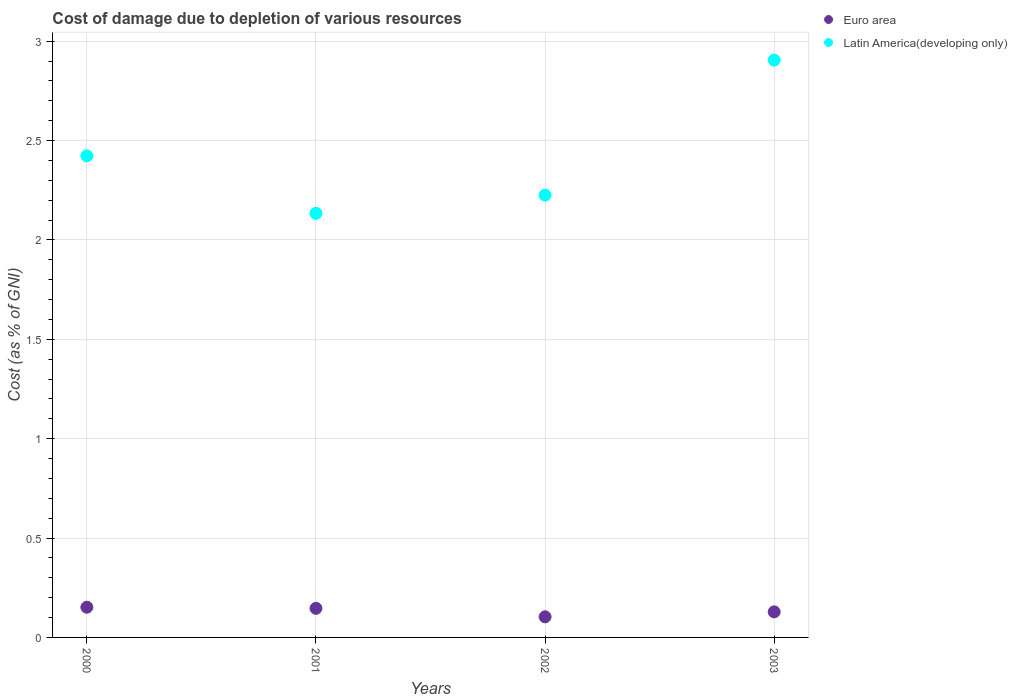How many different coloured dotlines are there?
Keep it short and to the point. 2. Is the number of dotlines equal to the number of legend labels?
Provide a short and direct response. Yes. What is the cost of damage caused due to the depletion of various resources in Euro area in 2002?
Keep it short and to the point. 0.1. Across all years, what is the maximum cost of damage caused due to the depletion of various resources in Euro area?
Give a very brief answer. 0.15. Across all years, what is the minimum cost of damage caused due to the depletion of various resources in Euro area?
Your response must be concise. 0.1. In which year was the cost of damage caused due to the depletion of various resources in Euro area maximum?
Provide a short and direct response. 2000. What is the total cost of damage caused due to the depletion of various resources in Latin America(developing only) in the graph?
Ensure brevity in your answer.  9.69. What is the difference between the cost of damage caused due to the depletion of various resources in Latin America(developing only) in 2000 and that in 2002?
Offer a very short reply. 0.2. What is the difference between the cost of damage caused due to the depletion of various resources in Latin America(developing only) in 2002 and the cost of damage caused due to the depletion of various resources in Euro area in 2000?
Keep it short and to the point. 2.07. What is the average cost of damage caused due to the depletion of various resources in Latin America(developing only) per year?
Keep it short and to the point. 2.42. In the year 2002, what is the difference between the cost of damage caused due to the depletion of various resources in Latin America(developing only) and cost of damage caused due to the depletion of various resources in Euro area?
Ensure brevity in your answer.  2.12. What is the ratio of the cost of damage caused due to the depletion of various resources in Latin America(developing only) in 2002 to that in 2003?
Your response must be concise. 0.77. What is the difference between the highest and the second highest cost of damage caused due to the depletion of various resources in Euro area?
Your answer should be compact. 0.01. What is the difference between the highest and the lowest cost of damage caused due to the depletion of various resources in Euro area?
Your answer should be compact. 0.05. Is the sum of the cost of damage caused due to the depletion of various resources in Latin America(developing only) in 2000 and 2003 greater than the maximum cost of damage caused due to the depletion of various resources in Euro area across all years?
Offer a terse response. Yes. Does the cost of damage caused due to the depletion of various resources in Euro area monotonically increase over the years?
Your answer should be very brief. No. How many dotlines are there?
Your answer should be compact. 2. How many years are there in the graph?
Offer a terse response. 4. Are the values on the major ticks of Y-axis written in scientific E-notation?
Give a very brief answer. No. Where does the legend appear in the graph?
Ensure brevity in your answer.  Top right. How many legend labels are there?
Give a very brief answer. 2. What is the title of the graph?
Keep it short and to the point. Cost of damage due to depletion of various resources. Does "Isle of Man" appear as one of the legend labels in the graph?
Make the answer very short. No. What is the label or title of the Y-axis?
Your answer should be compact. Cost (as % of GNI). What is the Cost (as % of GNI) of Euro area in 2000?
Provide a short and direct response. 0.15. What is the Cost (as % of GNI) of Latin America(developing only) in 2000?
Offer a terse response. 2.42. What is the Cost (as % of GNI) of Euro area in 2001?
Keep it short and to the point. 0.15. What is the Cost (as % of GNI) of Latin America(developing only) in 2001?
Keep it short and to the point. 2.13. What is the Cost (as % of GNI) in Euro area in 2002?
Provide a succinct answer. 0.1. What is the Cost (as % of GNI) of Latin America(developing only) in 2002?
Offer a terse response. 2.23. What is the Cost (as % of GNI) in Euro area in 2003?
Keep it short and to the point. 0.13. What is the Cost (as % of GNI) in Latin America(developing only) in 2003?
Your answer should be compact. 2.91. Across all years, what is the maximum Cost (as % of GNI) in Euro area?
Your answer should be very brief. 0.15. Across all years, what is the maximum Cost (as % of GNI) in Latin America(developing only)?
Ensure brevity in your answer.  2.91. Across all years, what is the minimum Cost (as % of GNI) of Euro area?
Ensure brevity in your answer.  0.1. Across all years, what is the minimum Cost (as % of GNI) in Latin America(developing only)?
Your response must be concise. 2.13. What is the total Cost (as % of GNI) of Euro area in the graph?
Provide a short and direct response. 0.53. What is the total Cost (as % of GNI) of Latin America(developing only) in the graph?
Make the answer very short. 9.69. What is the difference between the Cost (as % of GNI) of Euro area in 2000 and that in 2001?
Provide a succinct answer. 0.01. What is the difference between the Cost (as % of GNI) of Latin America(developing only) in 2000 and that in 2001?
Make the answer very short. 0.29. What is the difference between the Cost (as % of GNI) of Euro area in 2000 and that in 2002?
Keep it short and to the point. 0.05. What is the difference between the Cost (as % of GNI) of Latin America(developing only) in 2000 and that in 2002?
Your answer should be compact. 0.2. What is the difference between the Cost (as % of GNI) of Euro area in 2000 and that in 2003?
Your answer should be compact. 0.02. What is the difference between the Cost (as % of GNI) in Latin America(developing only) in 2000 and that in 2003?
Offer a very short reply. -0.48. What is the difference between the Cost (as % of GNI) in Euro area in 2001 and that in 2002?
Make the answer very short. 0.04. What is the difference between the Cost (as % of GNI) in Latin America(developing only) in 2001 and that in 2002?
Make the answer very short. -0.09. What is the difference between the Cost (as % of GNI) in Euro area in 2001 and that in 2003?
Offer a terse response. 0.02. What is the difference between the Cost (as % of GNI) in Latin America(developing only) in 2001 and that in 2003?
Ensure brevity in your answer.  -0.77. What is the difference between the Cost (as % of GNI) in Euro area in 2002 and that in 2003?
Keep it short and to the point. -0.03. What is the difference between the Cost (as % of GNI) of Latin America(developing only) in 2002 and that in 2003?
Ensure brevity in your answer.  -0.68. What is the difference between the Cost (as % of GNI) in Euro area in 2000 and the Cost (as % of GNI) in Latin America(developing only) in 2001?
Provide a succinct answer. -1.98. What is the difference between the Cost (as % of GNI) of Euro area in 2000 and the Cost (as % of GNI) of Latin America(developing only) in 2002?
Provide a short and direct response. -2.07. What is the difference between the Cost (as % of GNI) in Euro area in 2000 and the Cost (as % of GNI) in Latin America(developing only) in 2003?
Make the answer very short. -2.75. What is the difference between the Cost (as % of GNI) of Euro area in 2001 and the Cost (as % of GNI) of Latin America(developing only) in 2002?
Your answer should be compact. -2.08. What is the difference between the Cost (as % of GNI) in Euro area in 2001 and the Cost (as % of GNI) in Latin America(developing only) in 2003?
Make the answer very short. -2.76. What is the difference between the Cost (as % of GNI) of Euro area in 2002 and the Cost (as % of GNI) of Latin America(developing only) in 2003?
Offer a very short reply. -2.8. What is the average Cost (as % of GNI) in Euro area per year?
Provide a short and direct response. 0.13. What is the average Cost (as % of GNI) of Latin America(developing only) per year?
Give a very brief answer. 2.42. In the year 2000, what is the difference between the Cost (as % of GNI) in Euro area and Cost (as % of GNI) in Latin America(developing only)?
Offer a very short reply. -2.27. In the year 2001, what is the difference between the Cost (as % of GNI) in Euro area and Cost (as % of GNI) in Latin America(developing only)?
Give a very brief answer. -1.99. In the year 2002, what is the difference between the Cost (as % of GNI) in Euro area and Cost (as % of GNI) in Latin America(developing only)?
Offer a terse response. -2.12. In the year 2003, what is the difference between the Cost (as % of GNI) in Euro area and Cost (as % of GNI) in Latin America(developing only)?
Keep it short and to the point. -2.78. What is the ratio of the Cost (as % of GNI) of Euro area in 2000 to that in 2001?
Make the answer very short. 1.04. What is the ratio of the Cost (as % of GNI) in Latin America(developing only) in 2000 to that in 2001?
Keep it short and to the point. 1.14. What is the ratio of the Cost (as % of GNI) of Euro area in 2000 to that in 2002?
Make the answer very short. 1.47. What is the ratio of the Cost (as % of GNI) of Latin America(developing only) in 2000 to that in 2002?
Keep it short and to the point. 1.09. What is the ratio of the Cost (as % of GNI) in Euro area in 2000 to that in 2003?
Your answer should be compact. 1.18. What is the ratio of the Cost (as % of GNI) of Latin America(developing only) in 2000 to that in 2003?
Ensure brevity in your answer.  0.83. What is the ratio of the Cost (as % of GNI) in Euro area in 2001 to that in 2002?
Provide a short and direct response. 1.41. What is the ratio of the Cost (as % of GNI) of Latin America(developing only) in 2001 to that in 2002?
Keep it short and to the point. 0.96. What is the ratio of the Cost (as % of GNI) in Euro area in 2001 to that in 2003?
Make the answer very short. 1.14. What is the ratio of the Cost (as % of GNI) in Latin America(developing only) in 2001 to that in 2003?
Your response must be concise. 0.73. What is the ratio of the Cost (as % of GNI) in Euro area in 2002 to that in 2003?
Ensure brevity in your answer.  0.81. What is the ratio of the Cost (as % of GNI) in Latin America(developing only) in 2002 to that in 2003?
Provide a short and direct response. 0.77. What is the difference between the highest and the second highest Cost (as % of GNI) in Euro area?
Make the answer very short. 0.01. What is the difference between the highest and the second highest Cost (as % of GNI) of Latin America(developing only)?
Ensure brevity in your answer.  0.48. What is the difference between the highest and the lowest Cost (as % of GNI) in Euro area?
Provide a short and direct response. 0.05. What is the difference between the highest and the lowest Cost (as % of GNI) of Latin America(developing only)?
Offer a terse response. 0.77. 